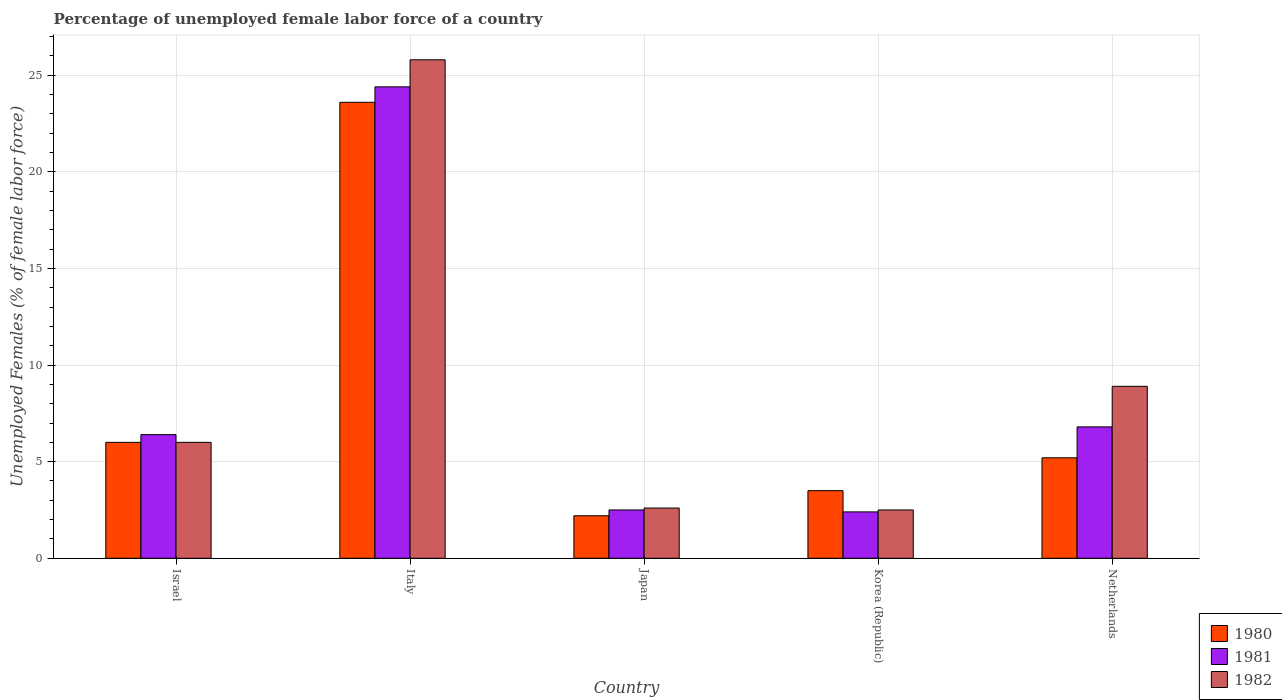How many groups of bars are there?
Make the answer very short. 5. Are the number of bars on each tick of the X-axis equal?
Keep it short and to the point. Yes. How many bars are there on the 4th tick from the left?
Your response must be concise. 3. In how many cases, is the number of bars for a given country not equal to the number of legend labels?
Provide a succinct answer. 0. What is the percentage of unemployed female labor force in 1981 in Israel?
Provide a succinct answer. 6.4. Across all countries, what is the maximum percentage of unemployed female labor force in 1980?
Make the answer very short. 23.6. Across all countries, what is the minimum percentage of unemployed female labor force in 1980?
Make the answer very short. 2.2. In which country was the percentage of unemployed female labor force in 1980 maximum?
Provide a succinct answer. Italy. In which country was the percentage of unemployed female labor force in 1981 minimum?
Your answer should be very brief. Korea (Republic). What is the total percentage of unemployed female labor force in 1981 in the graph?
Provide a short and direct response. 42.5. What is the difference between the percentage of unemployed female labor force in 1982 in Israel and that in Netherlands?
Ensure brevity in your answer.  -2.9. What is the difference between the percentage of unemployed female labor force in 1980 in Italy and the percentage of unemployed female labor force in 1982 in Korea (Republic)?
Your answer should be compact. 21.1. What is the average percentage of unemployed female labor force in 1980 per country?
Give a very brief answer. 8.1. What is the difference between the percentage of unemployed female labor force of/in 1980 and percentage of unemployed female labor force of/in 1982 in Korea (Republic)?
Give a very brief answer. 1. In how many countries, is the percentage of unemployed female labor force in 1981 greater than 2 %?
Offer a terse response. 5. What is the ratio of the percentage of unemployed female labor force in 1981 in Israel to that in Japan?
Your response must be concise. 2.56. Is the percentage of unemployed female labor force in 1981 in Korea (Republic) less than that in Netherlands?
Your answer should be very brief. Yes. What is the difference between the highest and the second highest percentage of unemployed female labor force in 1980?
Your answer should be compact. -0.8. What is the difference between the highest and the lowest percentage of unemployed female labor force in 1980?
Offer a terse response. 21.4. In how many countries, is the percentage of unemployed female labor force in 1982 greater than the average percentage of unemployed female labor force in 1982 taken over all countries?
Your answer should be very brief. 1. Is the sum of the percentage of unemployed female labor force in 1980 in Israel and Italy greater than the maximum percentage of unemployed female labor force in 1981 across all countries?
Provide a short and direct response. Yes. What does the 1st bar from the right in Korea (Republic) represents?
Provide a succinct answer. 1982. How many bars are there?
Offer a very short reply. 15. Are all the bars in the graph horizontal?
Make the answer very short. No. How many countries are there in the graph?
Your response must be concise. 5. Does the graph contain grids?
Provide a succinct answer. Yes. Where does the legend appear in the graph?
Provide a succinct answer. Bottom right. How many legend labels are there?
Offer a terse response. 3. What is the title of the graph?
Provide a succinct answer. Percentage of unemployed female labor force of a country. Does "2011" appear as one of the legend labels in the graph?
Keep it short and to the point. No. What is the label or title of the X-axis?
Provide a succinct answer. Country. What is the label or title of the Y-axis?
Offer a terse response. Unemployed Females (% of female labor force). What is the Unemployed Females (% of female labor force) of 1981 in Israel?
Give a very brief answer. 6.4. What is the Unemployed Females (% of female labor force) in 1980 in Italy?
Offer a very short reply. 23.6. What is the Unemployed Females (% of female labor force) of 1981 in Italy?
Provide a short and direct response. 24.4. What is the Unemployed Females (% of female labor force) in 1982 in Italy?
Ensure brevity in your answer.  25.8. What is the Unemployed Females (% of female labor force) of 1980 in Japan?
Provide a succinct answer. 2.2. What is the Unemployed Females (% of female labor force) of 1982 in Japan?
Your answer should be very brief. 2.6. What is the Unemployed Females (% of female labor force) in 1980 in Korea (Republic)?
Your response must be concise. 3.5. What is the Unemployed Females (% of female labor force) in 1981 in Korea (Republic)?
Keep it short and to the point. 2.4. What is the Unemployed Females (% of female labor force) of 1980 in Netherlands?
Provide a succinct answer. 5.2. What is the Unemployed Females (% of female labor force) of 1981 in Netherlands?
Offer a terse response. 6.8. What is the Unemployed Females (% of female labor force) in 1982 in Netherlands?
Offer a terse response. 8.9. Across all countries, what is the maximum Unemployed Females (% of female labor force) in 1980?
Offer a very short reply. 23.6. Across all countries, what is the maximum Unemployed Females (% of female labor force) of 1981?
Provide a short and direct response. 24.4. Across all countries, what is the maximum Unemployed Females (% of female labor force) in 1982?
Your answer should be very brief. 25.8. Across all countries, what is the minimum Unemployed Females (% of female labor force) in 1980?
Ensure brevity in your answer.  2.2. Across all countries, what is the minimum Unemployed Females (% of female labor force) in 1981?
Make the answer very short. 2.4. What is the total Unemployed Females (% of female labor force) of 1980 in the graph?
Give a very brief answer. 40.5. What is the total Unemployed Females (% of female labor force) in 1981 in the graph?
Your answer should be compact. 42.5. What is the total Unemployed Females (% of female labor force) in 1982 in the graph?
Ensure brevity in your answer.  45.8. What is the difference between the Unemployed Females (% of female labor force) of 1980 in Israel and that in Italy?
Offer a terse response. -17.6. What is the difference between the Unemployed Females (% of female labor force) in 1982 in Israel and that in Italy?
Ensure brevity in your answer.  -19.8. What is the difference between the Unemployed Females (% of female labor force) of 1980 in Israel and that in Japan?
Provide a short and direct response. 3.8. What is the difference between the Unemployed Females (% of female labor force) in 1980 in Israel and that in Korea (Republic)?
Provide a succinct answer. 2.5. What is the difference between the Unemployed Females (% of female labor force) in 1981 in Israel and that in Korea (Republic)?
Offer a very short reply. 4. What is the difference between the Unemployed Females (% of female labor force) of 1982 in Israel and that in Korea (Republic)?
Keep it short and to the point. 3.5. What is the difference between the Unemployed Females (% of female labor force) of 1980 in Italy and that in Japan?
Provide a succinct answer. 21.4. What is the difference between the Unemployed Females (% of female labor force) of 1981 in Italy and that in Japan?
Ensure brevity in your answer.  21.9. What is the difference between the Unemployed Females (% of female labor force) in 1982 in Italy and that in Japan?
Offer a terse response. 23.2. What is the difference between the Unemployed Females (% of female labor force) in 1980 in Italy and that in Korea (Republic)?
Your response must be concise. 20.1. What is the difference between the Unemployed Females (% of female labor force) in 1982 in Italy and that in Korea (Republic)?
Provide a short and direct response. 23.3. What is the difference between the Unemployed Females (% of female labor force) of 1980 in Italy and that in Netherlands?
Offer a very short reply. 18.4. What is the difference between the Unemployed Females (% of female labor force) in 1982 in Japan and that in Korea (Republic)?
Keep it short and to the point. 0.1. What is the difference between the Unemployed Females (% of female labor force) in 1982 in Japan and that in Netherlands?
Provide a short and direct response. -6.3. What is the difference between the Unemployed Females (% of female labor force) of 1980 in Korea (Republic) and that in Netherlands?
Your answer should be compact. -1.7. What is the difference between the Unemployed Females (% of female labor force) of 1981 in Korea (Republic) and that in Netherlands?
Give a very brief answer. -4.4. What is the difference between the Unemployed Females (% of female labor force) of 1982 in Korea (Republic) and that in Netherlands?
Offer a very short reply. -6.4. What is the difference between the Unemployed Females (% of female labor force) of 1980 in Israel and the Unemployed Females (% of female labor force) of 1981 in Italy?
Ensure brevity in your answer.  -18.4. What is the difference between the Unemployed Females (% of female labor force) of 1980 in Israel and the Unemployed Females (% of female labor force) of 1982 in Italy?
Provide a short and direct response. -19.8. What is the difference between the Unemployed Females (% of female labor force) in 1981 in Israel and the Unemployed Females (% of female labor force) in 1982 in Italy?
Provide a succinct answer. -19.4. What is the difference between the Unemployed Females (% of female labor force) of 1980 in Israel and the Unemployed Females (% of female labor force) of 1982 in Japan?
Provide a short and direct response. 3.4. What is the difference between the Unemployed Females (% of female labor force) of 1980 in Israel and the Unemployed Females (% of female labor force) of 1982 in Korea (Republic)?
Give a very brief answer. 3.5. What is the difference between the Unemployed Females (% of female labor force) of 1981 in Israel and the Unemployed Females (% of female labor force) of 1982 in Korea (Republic)?
Your response must be concise. 3.9. What is the difference between the Unemployed Females (% of female labor force) in 1980 in Israel and the Unemployed Females (% of female labor force) in 1982 in Netherlands?
Keep it short and to the point. -2.9. What is the difference between the Unemployed Females (% of female labor force) of 1980 in Italy and the Unemployed Females (% of female labor force) of 1981 in Japan?
Provide a short and direct response. 21.1. What is the difference between the Unemployed Females (% of female labor force) in 1981 in Italy and the Unemployed Females (% of female labor force) in 1982 in Japan?
Offer a terse response. 21.8. What is the difference between the Unemployed Females (% of female labor force) in 1980 in Italy and the Unemployed Females (% of female labor force) in 1981 in Korea (Republic)?
Provide a succinct answer. 21.2. What is the difference between the Unemployed Females (% of female labor force) in 1980 in Italy and the Unemployed Females (% of female labor force) in 1982 in Korea (Republic)?
Give a very brief answer. 21.1. What is the difference between the Unemployed Females (% of female labor force) of 1981 in Italy and the Unemployed Females (% of female labor force) of 1982 in Korea (Republic)?
Keep it short and to the point. 21.9. What is the difference between the Unemployed Females (% of female labor force) in 1981 in Italy and the Unemployed Females (% of female labor force) in 1982 in Netherlands?
Offer a very short reply. 15.5. What is the difference between the Unemployed Females (% of female labor force) in 1981 in Japan and the Unemployed Females (% of female labor force) in 1982 in Korea (Republic)?
Keep it short and to the point. 0. What is the difference between the Unemployed Females (% of female labor force) of 1981 in Japan and the Unemployed Females (% of female labor force) of 1982 in Netherlands?
Provide a succinct answer. -6.4. What is the difference between the Unemployed Females (% of female labor force) of 1980 in Korea (Republic) and the Unemployed Females (% of female labor force) of 1982 in Netherlands?
Provide a succinct answer. -5.4. What is the average Unemployed Females (% of female labor force) of 1980 per country?
Your answer should be very brief. 8.1. What is the average Unemployed Females (% of female labor force) in 1982 per country?
Make the answer very short. 9.16. What is the difference between the Unemployed Females (% of female labor force) in 1981 and Unemployed Females (% of female labor force) in 1982 in Israel?
Keep it short and to the point. 0.4. What is the difference between the Unemployed Females (% of female labor force) in 1980 and Unemployed Females (% of female labor force) in 1982 in Italy?
Make the answer very short. -2.2. What is the difference between the Unemployed Females (% of female labor force) in 1980 and Unemployed Females (% of female labor force) in 1981 in Japan?
Ensure brevity in your answer.  -0.3. What is the difference between the Unemployed Females (% of female labor force) of 1980 and Unemployed Females (% of female labor force) of 1982 in Japan?
Your answer should be compact. -0.4. What is the difference between the Unemployed Females (% of female labor force) in 1981 and Unemployed Females (% of female labor force) in 1982 in Japan?
Your response must be concise. -0.1. What is the difference between the Unemployed Females (% of female labor force) of 1980 and Unemployed Females (% of female labor force) of 1981 in Korea (Republic)?
Offer a very short reply. 1.1. What is the difference between the Unemployed Females (% of female labor force) in 1980 and Unemployed Females (% of female labor force) in 1981 in Netherlands?
Offer a terse response. -1.6. What is the difference between the Unemployed Females (% of female labor force) in 1980 and Unemployed Females (% of female labor force) in 1982 in Netherlands?
Provide a succinct answer. -3.7. What is the difference between the Unemployed Females (% of female labor force) in 1981 and Unemployed Females (% of female labor force) in 1982 in Netherlands?
Your response must be concise. -2.1. What is the ratio of the Unemployed Females (% of female labor force) in 1980 in Israel to that in Italy?
Your answer should be very brief. 0.25. What is the ratio of the Unemployed Females (% of female labor force) in 1981 in Israel to that in Italy?
Give a very brief answer. 0.26. What is the ratio of the Unemployed Females (% of female labor force) of 1982 in Israel to that in Italy?
Your answer should be very brief. 0.23. What is the ratio of the Unemployed Females (% of female labor force) of 1980 in Israel to that in Japan?
Your response must be concise. 2.73. What is the ratio of the Unemployed Females (% of female labor force) in 1981 in Israel to that in Japan?
Make the answer very short. 2.56. What is the ratio of the Unemployed Females (% of female labor force) of 1982 in Israel to that in Japan?
Your response must be concise. 2.31. What is the ratio of the Unemployed Females (% of female labor force) in 1980 in Israel to that in Korea (Republic)?
Offer a very short reply. 1.71. What is the ratio of the Unemployed Females (% of female labor force) of 1981 in Israel to that in Korea (Republic)?
Offer a very short reply. 2.67. What is the ratio of the Unemployed Females (% of female labor force) in 1980 in Israel to that in Netherlands?
Offer a very short reply. 1.15. What is the ratio of the Unemployed Females (% of female labor force) of 1981 in Israel to that in Netherlands?
Ensure brevity in your answer.  0.94. What is the ratio of the Unemployed Females (% of female labor force) in 1982 in Israel to that in Netherlands?
Your response must be concise. 0.67. What is the ratio of the Unemployed Females (% of female labor force) of 1980 in Italy to that in Japan?
Give a very brief answer. 10.73. What is the ratio of the Unemployed Females (% of female labor force) of 1981 in Italy to that in Japan?
Provide a short and direct response. 9.76. What is the ratio of the Unemployed Females (% of female labor force) of 1982 in Italy to that in Japan?
Your response must be concise. 9.92. What is the ratio of the Unemployed Females (% of female labor force) in 1980 in Italy to that in Korea (Republic)?
Keep it short and to the point. 6.74. What is the ratio of the Unemployed Females (% of female labor force) of 1981 in Italy to that in Korea (Republic)?
Your answer should be compact. 10.17. What is the ratio of the Unemployed Females (% of female labor force) of 1982 in Italy to that in Korea (Republic)?
Give a very brief answer. 10.32. What is the ratio of the Unemployed Females (% of female labor force) of 1980 in Italy to that in Netherlands?
Your answer should be compact. 4.54. What is the ratio of the Unemployed Females (% of female labor force) in 1981 in Italy to that in Netherlands?
Offer a terse response. 3.59. What is the ratio of the Unemployed Females (% of female labor force) of 1982 in Italy to that in Netherlands?
Your answer should be compact. 2.9. What is the ratio of the Unemployed Females (% of female labor force) of 1980 in Japan to that in Korea (Republic)?
Your response must be concise. 0.63. What is the ratio of the Unemployed Females (% of female labor force) of 1981 in Japan to that in Korea (Republic)?
Provide a short and direct response. 1.04. What is the ratio of the Unemployed Females (% of female labor force) in 1982 in Japan to that in Korea (Republic)?
Your response must be concise. 1.04. What is the ratio of the Unemployed Females (% of female labor force) in 1980 in Japan to that in Netherlands?
Your response must be concise. 0.42. What is the ratio of the Unemployed Females (% of female labor force) of 1981 in Japan to that in Netherlands?
Keep it short and to the point. 0.37. What is the ratio of the Unemployed Females (% of female labor force) in 1982 in Japan to that in Netherlands?
Provide a short and direct response. 0.29. What is the ratio of the Unemployed Females (% of female labor force) of 1980 in Korea (Republic) to that in Netherlands?
Make the answer very short. 0.67. What is the ratio of the Unemployed Females (% of female labor force) of 1981 in Korea (Republic) to that in Netherlands?
Offer a terse response. 0.35. What is the ratio of the Unemployed Females (% of female labor force) in 1982 in Korea (Republic) to that in Netherlands?
Your answer should be very brief. 0.28. What is the difference between the highest and the second highest Unemployed Females (% of female labor force) of 1980?
Your answer should be compact. 17.6. What is the difference between the highest and the second highest Unemployed Females (% of female labor force) of 1981?
Provide a short and direct response. 17.6. What is the difference between the highest and the second highest Unemployed Females (% of female labor force) in 1982?
Provide a short and direct response. 16.9. What is the difference between the highest and the lowest Unemployed Females (% of female labor force) in 1980?
Provide a succinct answer. 21.4. What is the difference between the highest and the lowest Unemployed Females (% of female labor force) of 1981?
Your response must be concise. 22. What is the difference between the highest and the lowest Unemployed Females (% of female labor force) in 1982?
Provide a short and direct response. 23.3. 